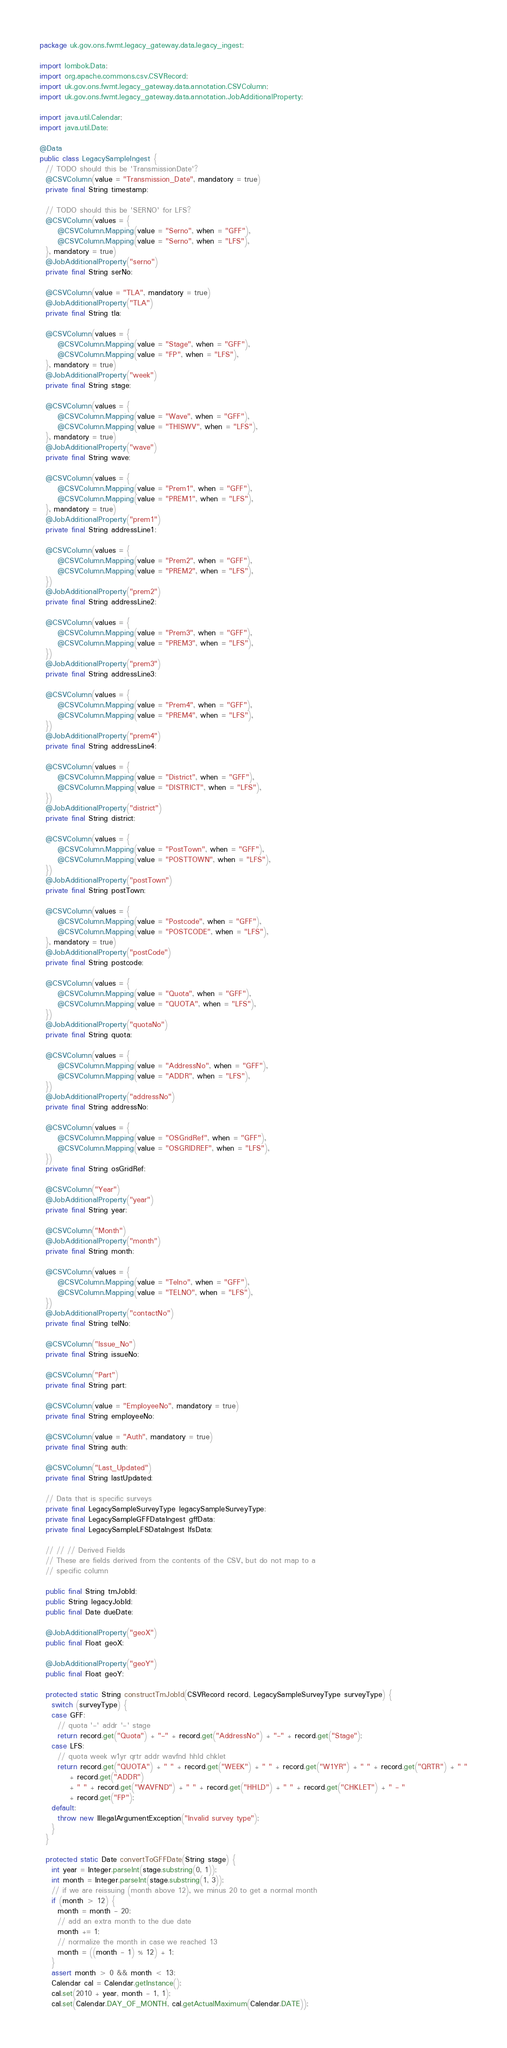<code> <loc_0><loc_0><loc_500><loc_500><_Java_>package uk.gov.ons.fwmt.legacy_gateway.data.legacy_ingest;

import lombok.Data;
import org.apache.commons.csv.CSVRecord;
import uk.gov.ons.fwmt.legacy_gateway.data.annotation.CSVColumn;
import uk.gov.ons.fwmt.legacy_gateway.data.annotation.JobAdditionalProperty;

import java.util.Calendar;
import java.util.Date;

@Data
public class LegacySampleIngest {
  // TODO should this be 'TransmissionDate'?
  @CSVColumn(value = "Transmission_Date", mandatory = true)
  private final String timestamp;

  // TODO should this be 'SERNO' for LFS?
  @CSVColumn(values = {
      @CSVColumn.Mapping(value = "Serno", when = "GFF"),
      @CSVColumn.Mapping(value = "Serno", when = "LFS"),
  }, mandatory = true)
  @JobAdditionalProperty("serno")
  private final String serNo;

  @CSVColumn(value = "TLA", mandatory = true)
  @JobAdditionalProperty("TLA")
  private final String tla;

  @CSVColumn(values = {
      @CSVColumn.Mapping(value = "Stage", when = "GFF"),
      @CSVColumn.Mapping(value = "FP", when = "LFS"),
  }, mandatory = true)
  @JobAdditionalProperty("week")
  private final String stage;

  @CSVColumn(values = {
      @CSVColumn.Mapping(value = "Wave", when = "GFF"),
      @CSVColumn.Mapping(value = "THISWV", when = "LFS"),
  }, mandatory = true)
  @JobAdditionalProperty("wave")
  private final String wave;

  @CSVColumn(values = {
      @CSVColumn.Mapping(value = "Prem1", when = "GFF"),
      @CSVColumn.Mapping(value = "PREM1", when = "LFS"),
  }, mandatory = true)
  @JobAdditionalProperty("prem1")
  private final String addressLine1;

  @CSVColumn(values = {
      @CSVColumn.Mapping(value = "Prem2", when = "GFF"),
      @CSVColumn.Mapping(value = "PREM2", when = "LFS"),
  })
  @JobAdditionalProperty("prem2")
  private final String addressLine2;

  @CSVColumn(values = {
      @CSVColumn.Mapping(value = "Prem3", when = "GFF"),
      @CSVColumn.Mapping(value = "PREM3", when = "LFS"),
  })
  @JobAdditionalProperty("prem3")
  private final String addressLine3;

  @CSVColumn(values = {
      @CSVColumn.Mapping(value = "Prem4", when = "GFF"),
      @CSVColumn.Mapping(value = "PREM4", when = "LFS"),
  })
  @JobAdditionalProperty("prem4")
  private final String addressLine4;

  @CSVColumn(values = {
      @CSVColumn.Mapping(value = "District", when = "GFF"),
      @CSVColumn.Mapping(value = "DISTRICT", when = "LFS"),
  })
  @JobAdditionalProperty("district")
  private final String district;

  @CSVColumn(values = {
      @CSVColumn.Mapping(value = "PostTown", when = "GFF"),
      @CSVColumn.Mapping(value = "POSTTOWN", when = "LFS"),
  })
  @JobAdditionalProperty("postTown")
  private final String postTown;

  @CSVColumn(values = {
      @CSVColumn.Mapping(value = "Postcode", when = "GFF"),
      @CSVColumn.Mapping(value = "POSTCODE", when = "LFS"),
  }, mandatory = true)
  @JobAdditionalProperty("postCode")
  private final String postcode;

  @CSVColumn(values = {
      @CSVColumn.Mapping(value = "Quota", when = "GFF"),
      @CSVColumn.Mapping(value = "QUOTA", when = "LFS"),
  })
  @JobAdditionalProperty("quotaNo")
  private final String quota;

  @CSVColumn(values = {
      @CSVColumn.Mapping(value = "AddressNo", when = "GFF"),
      @CSVColumn.Mapping(value = "ADDR", when = "LFS"),
  })
  @JobAdditionalProperty("addressNo")
  private final String addressNo;

  @CSVColumn(values = {
      @CSVColumn.Mapping(value = "OSGridRef", when = "GFF"),
      @CSVColumn.Mapping(value = "OSGRIDREF", when = "LFS"),
  })
  private final String osGridRef;

  @CSVColumn("Year")
  @JobAdditionalProperty("year")
  private final String year;

  @CSVColumn("Month")
  @JobAdditionalProperty("month")
  private final String month;

  @CSVColumn(values = {
      @CSVColumn.Mapping(value = "Telno", when = "GFF"),
      @CSVColumn.Mapping(value = "TELNO", when = "LFS"),
  })
  @JobAdditionalProperty("contactNo")
  private final String telNo;

  @CSVColumn("Issue_No")
  private final String issueNo;

  @CSVColumn("Part")
  private final String part;

  @CSVColumn(value = "EmployeeNo", mandatory = true)
  private final String employeeNo;

  @CSVColumn(value = "Auth", mandatory = true)
  private final String auth;

  @CSVColumn("Last_Updated")
  private final String lastUpdated;

  // Data that is specific surveys
  private final LegacySampleSurveyType legacySampleSurveyType;
  private final LegacySampleGFFDataIngest gffData;
  private final LegacySampleLFSDataIngest lfsData;

  // // // Derived Fields
  // These are fields derived from the contents of the CSV, but do not map to a
  // specific column

  public final String tmJobId;
  public String legacyJobId;
  public final Date dueDate;

  @JobAdditionalProperty("geoX")
  public final Float geoX;

  @JobAdditionalProperty("geoY")
  public final Float geoY;

  protected static String constructTmJobId(CSVRecord record, LegacySampleSurveyType surveyType) {
    switch (surveyType) {
    case GFF:
      // quota '-' addr '-' stage
      return record.get("Quota") + "-" + record.get("AddressNo") + "-" + record.get("Stage");
    case LFS:
      // quota week w1yr qrtr addr wavfnd hhld chklet
      return record.get("QUOTA") + " " + record.get("WEEK") + " " + record.get("W1YR") + " " + record.get("QRTR") + " "
          + record.get("ADDR")
          + " " + record.get("WAVFND") + " " + record.get("HHLD") + " " + record.get("CHKLET") + " - "
          + record.get("FP");
    default:
      throw new IllegalArgumentException("Invalid survey type");
    }
  }

  protected static Date convertToGFFDate(String stage) {
    int year = Integer.parseInt(stage.substring(0, 1));
    int month = Integer.parseInt(stage.substring(1, 3));
    // if we are reissuing (month above 12), we minus 20 to get a normal month
    if (month > 12) {
      month = month - 20;
      // add an extra month to the due date
      month += 1;
      // normalize the month in case we reached 13
      month = ((month - 1) % 12) + 1;
    }
    assert month > 0 && month < 13;
    Calendar cal = Calendar.getInstance();
    cal.set(2010 + year, month - 1, 1);
    cal.set(Calendar.DAY_OF_MONTH, cal.getActualMaximum(Calendar.DATE));</code> 